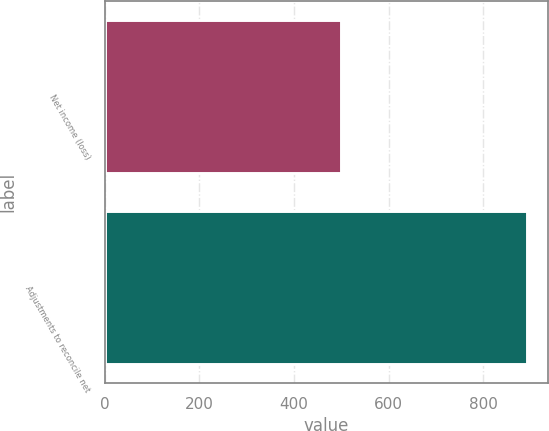<chart> <loc_0><loc_0><loc_500><loc_500><bar_chart><fcel>Net income (loss)<fcel>Adjustments to reconcile net<nl><fcel>500<fcel>892<nl></chart> 